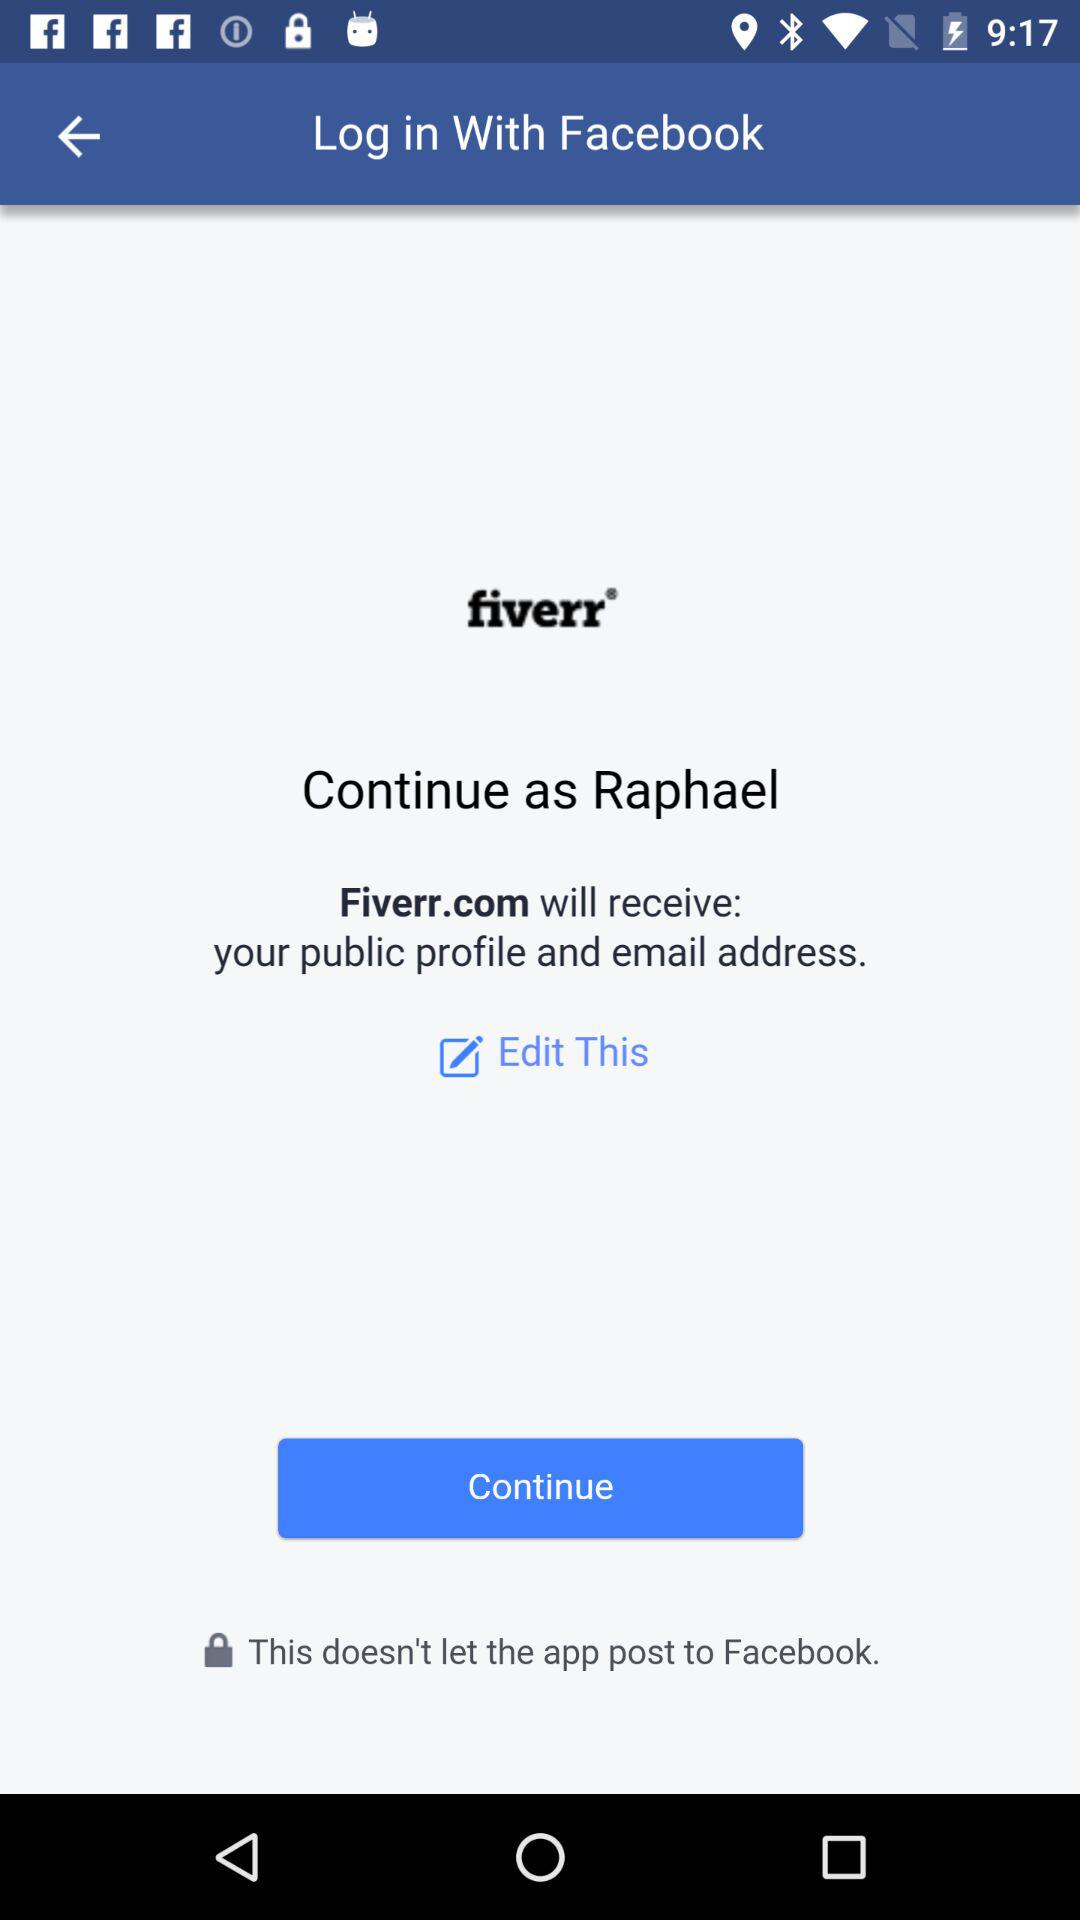What information will Fiverr.com receive? The application Fiverr.com will receive information about your public profile and email address. 